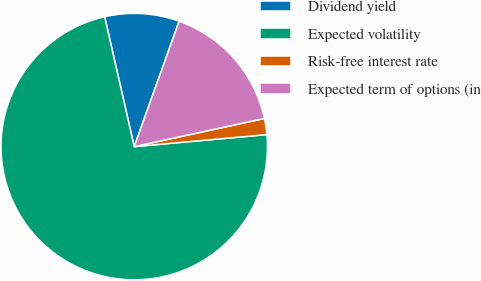Convert chart to OTSL. <chart><loc_0><loc_0><loc_500><loc_500><pie_chart><fcel>Dividend yield<fcel>Expected volatility<fcel>Risk-free interest rate<fcel>Expected term of options (in<nl><fcel>9.04%<fcel>72.87%<fcel>1.95%<fcel>16.13%<nl></chart> 